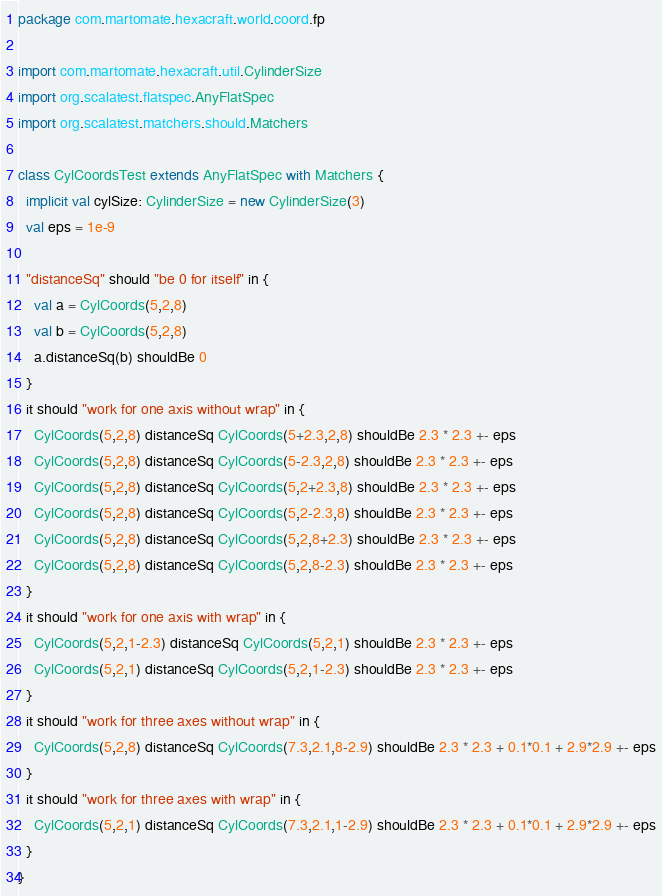<code> <loc_0><loc_0><loc_500><loc_500><_Scala_>package com.martomate.hexacraft.world.coord.fp

import com.martomate.hexacraft.util.CylinderSize
import org.scalatest.flatspec.AnyFlatSpec
import org.scalatest.matchers.should.Matchers

class CylCoordsTest extends AnyFlatSpec with Matchers {
  implicit val cylSize: CylinderSize = new CylinderSize(3)
  val eps = 1e-9

  "distanceSq" should "be 0 for itself" in {
    val a = CylCoords(5,2,8)
    val b = CylCoords(5,2,8)
    a.distanceSq(b) shouldBe 0
  }
  it should "work for one axis without wrap" in {
    CylCoords(5,2,8) distanceSq CylCoords(5+2.3,2,8) shouldBe 2.3 * 2.3 +- eps
    CylCoords(5,2,8) distanceSq CylCoords(5-2.3,2,8) shouldBe 2.3 * 2.3 +- eps
    CylCoords(5,2,8) distanceSq CylCoords(5,2+2.3,8) shouldBe 2.3 * 2.3 +- eps
    CylCoords(5,2,8) distanceSq CylCoords(5,2-2.3,8) shouldBe 2.3 * 2.3 +- eps
    CylCoords(5,2,8) distanceSq CylCoords(5,2,8+2.3) shouldBe 2.3 * 2.3 +- eps
    CylCoords(5,2,8) distanceSq CylCoords(5,2,8-2.3) shouldBe 2.3 * 2.3 +- eps
  }
  it should "work for one axis with wrap" in {
    CylCoords(5,2,1-2.3) distanceSq CylCoords(5,2,1) shouldBe 2.3 * 2.3 +- eps
    CylCoords(5,2,1) distanceSq CylCoords(5,2,1-2.3) shouldBe 2.3 * 2.3 +- eps
  }
  it should "work for three axes without wrap" in {
    CylCoords(5,2,8) distanceSq CylCoords(7.3,2.1,8-2.9) shouldBe 2.3 * 2.3 + 0.1*0.1 + 2.9*2.9 +- eps
  }
  it should "work for three axes with wrap" in {
    CylCoords(5,2,1) distanceSq CylCoords(7.3,2.1,1-2.9) shouldBe 2.3 * 2.3 + 0.1*0.1 + 2.9*2.9 +- eps
  }
}
</code> 